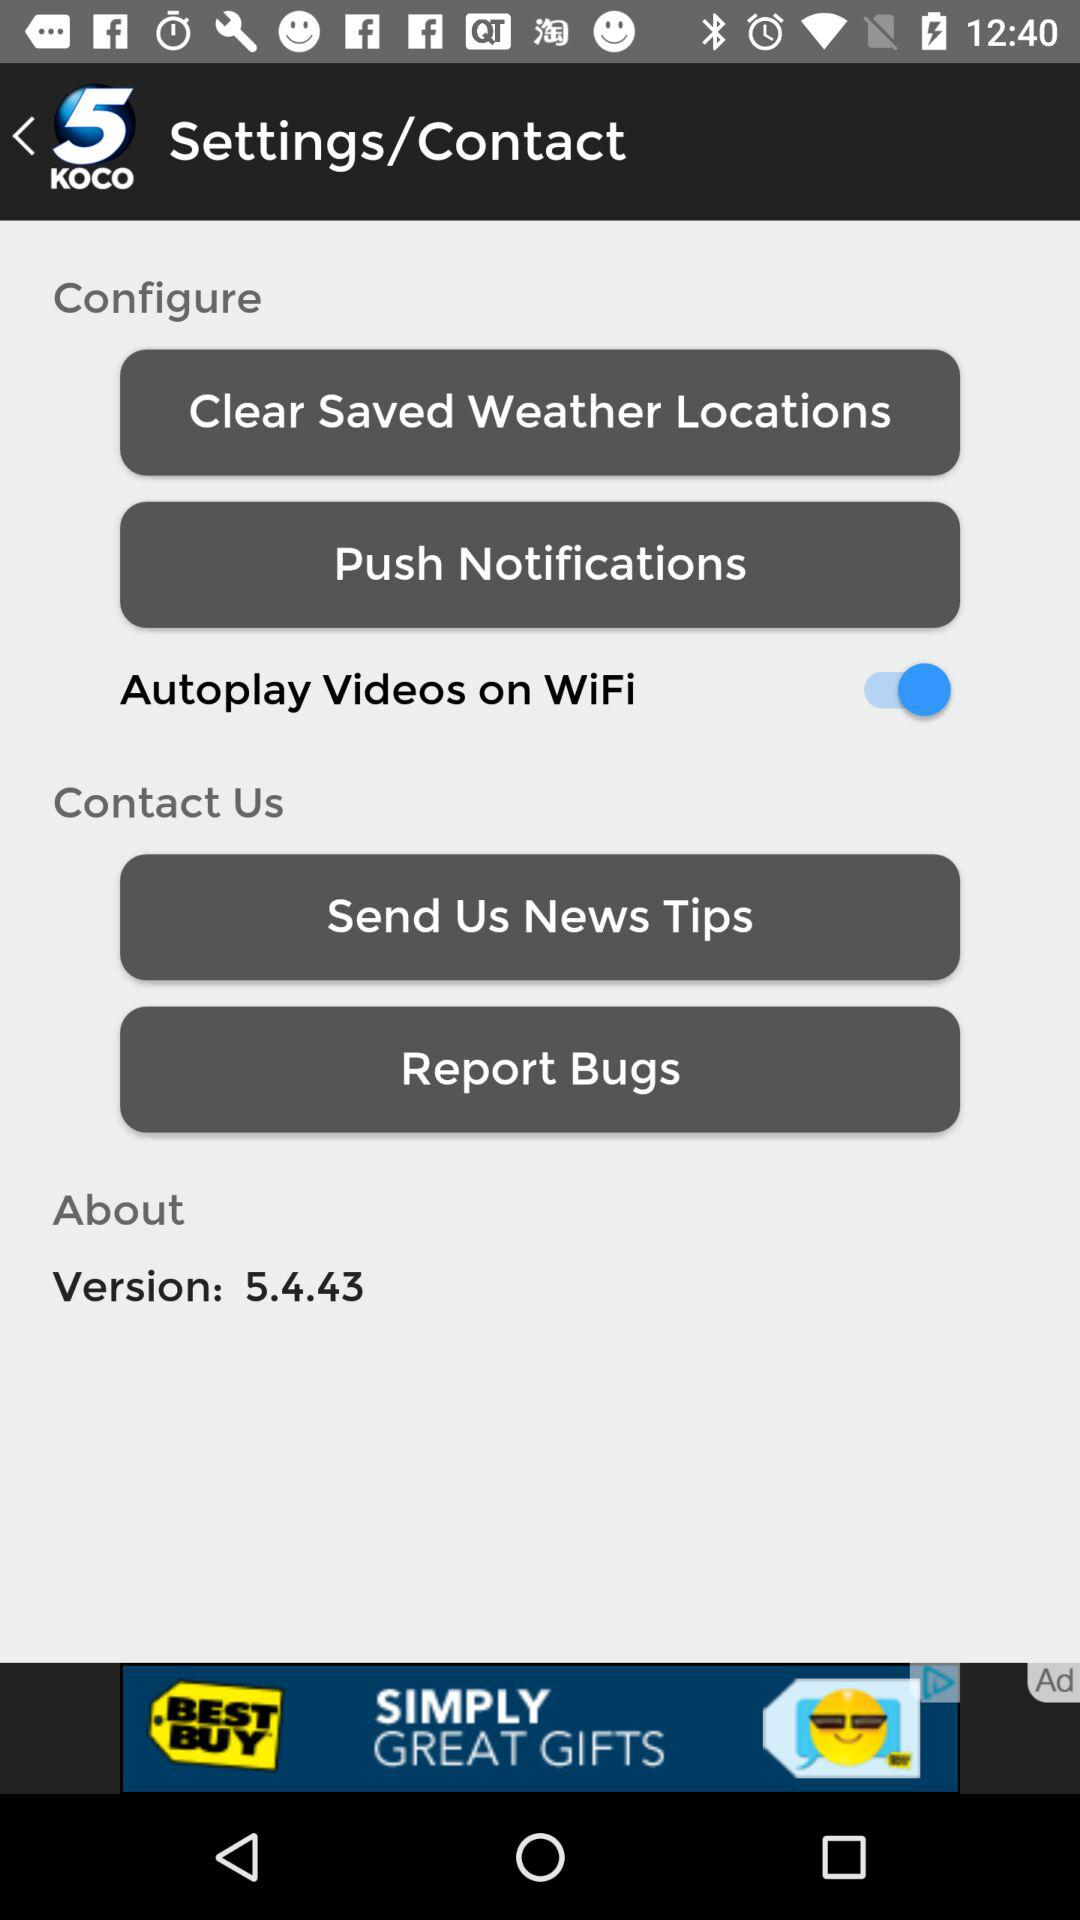What is the name of the application? The name of the application is "5 KOCO". 